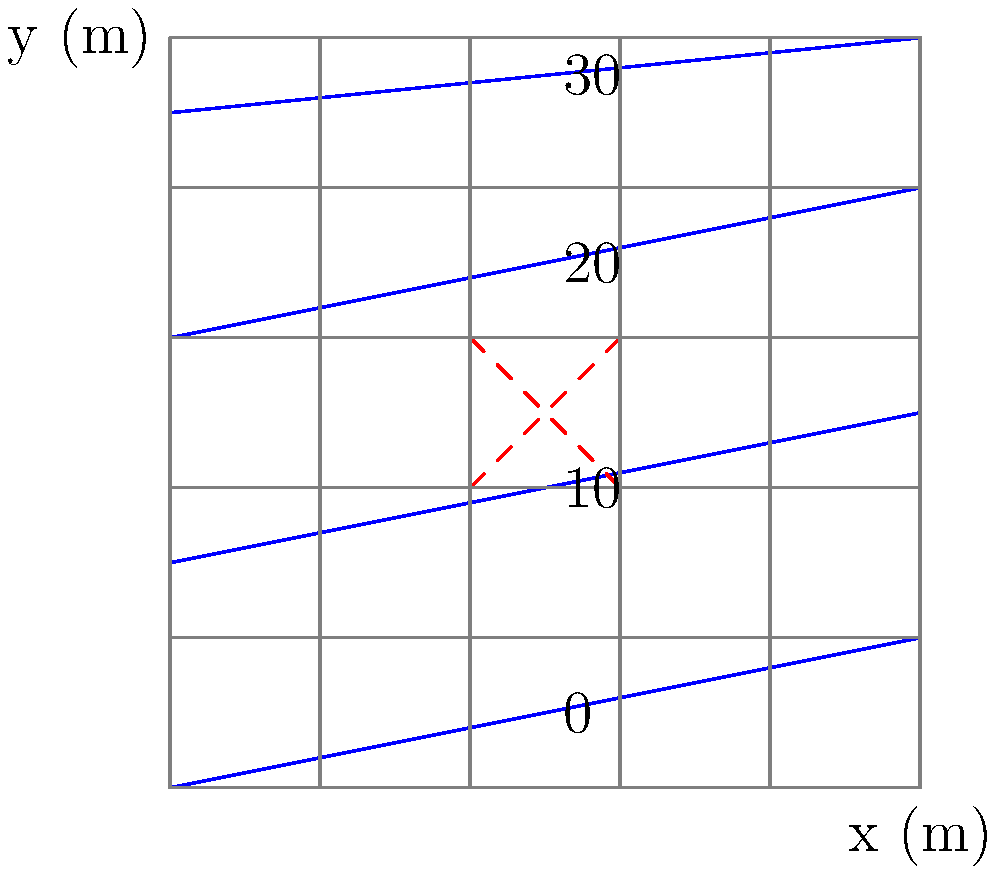En el mapa topográfico proporcionado, se está considerando la construcción de un estadio en el área marcada con líneas rojas discontinuas. ¿Cuál es la diferencia de elevación aproximada entre los puntos más alto y más bajo dentro del área propuesta para el estadio? Para determinar la diferencia de elevación dentro del área propuesta para el estadio, seguiremos estos pasos:

1. Identificar las líneas de contorno que atraviesan o están más cerca del área del estadio propuesto.
2. Determinar la elevación de estas líneas de contorno.
3. Identificar la elevación más alta y más baja dentro del área.
4. Calcular la diferencia entre estas elevaciones.

Analizando el mapa:

1. El área del estadio está marcada con líneas rojas discontinuas en forma de X.
2. Observamos que las líneas de contorno están etiquetadas con valores de 0, 10, 20, y 30.
3. El área del estadio es atravesada principalmente por dos líneas de contorno:
   - La línea de contorno inferior, que tiene una elevación de 10 unidades.
   - La línea de contorno superior, que tiene una elevación de 20 unidades.
4. La diferencia de elevación es:
   $$20 \text{ unidades} - 10 \text{ unidades} = 10 \text{ unidades}$$

Por lo tanto, la diferencia de elevación aproximada entre los puntos más alto y más bajo dentro del área propuesta para el estadio es de 10 unidades.
Answer: 10 unidades 